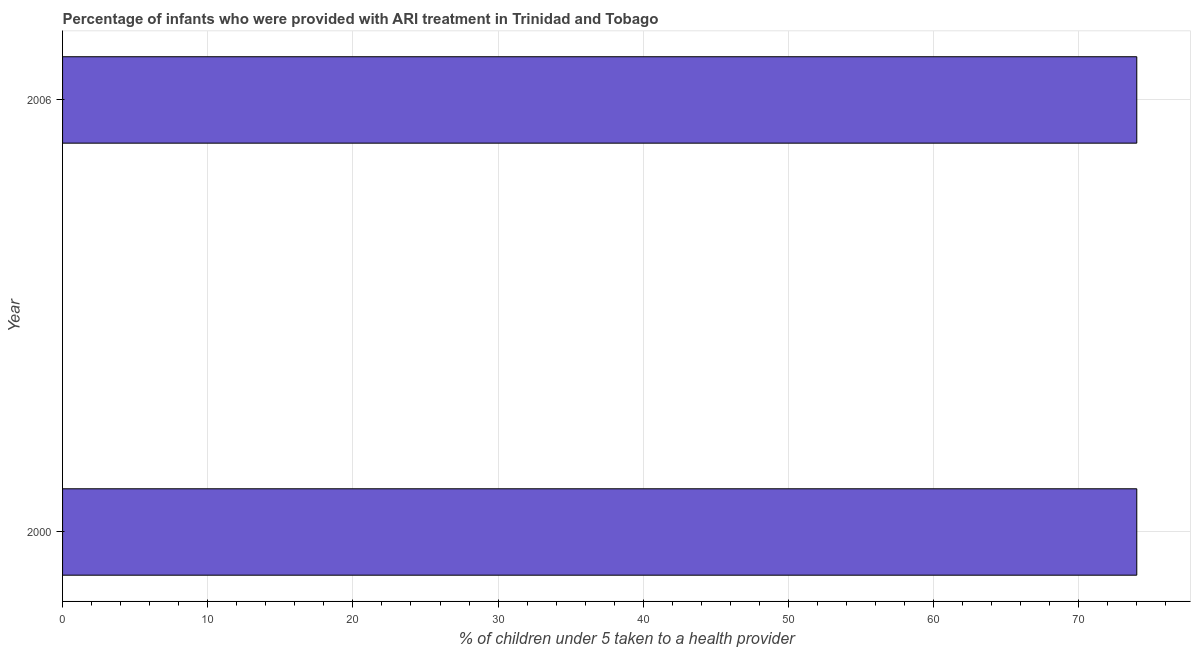Does the graph contain any zero values?
Your response must be concise. No. Does the graph contain grids?
Your answer should be compact. Yes. What is the title of the graph?
Your answer should be very brief. Percentage of infants who were provided with ARI treatment in Trinidad and Tobago. What is the label or title of the X-axis?
Give a very brief answer. % of children under 5 taken to a health provider. What is the percentage of children who were provided with ari treatment in 2000?
Your response must be concise. 74. What is the sum of the percentage of children who were provided with ari treatment?
Your response must be concise. 148. What is the difference between the percentage of children who were provided with ari treatment in 2000 and 2006?
Provide a short and direct response. 0. What is the median percentage of children who were provided with ari treatment?
Keep it short and to the point. 74. Do a majority of the years between 2000 and 2006 (inclusive) have percentage of children who were provided with ari treatment greater than 68 %?
Offer a very short reply. Yes. What is the ratio of the percentage of children who were provided with ari treatment in 2000 to that in 2006?
Your response must be concise. 1. Is the percentage of children who were provided with ari treatment in 2000 less than that in 2006?
Provide a short and direct response. No. How many bars are there?
Your answer should be compact. 2. What is the difference between two consecutive major ticks on the X-axis?
Offer a terse response. 10. Are the values on the major ticks of X-axis written in scientific E-notation?
Make the answer very short. No. What is the % of children under 5 taken to a health provider of 2006?
Give a very brief answer. 74. What is the difference between the % of children under 5 taken to a health provider in 2000 and 2006?
Offer a terse response. 0. 